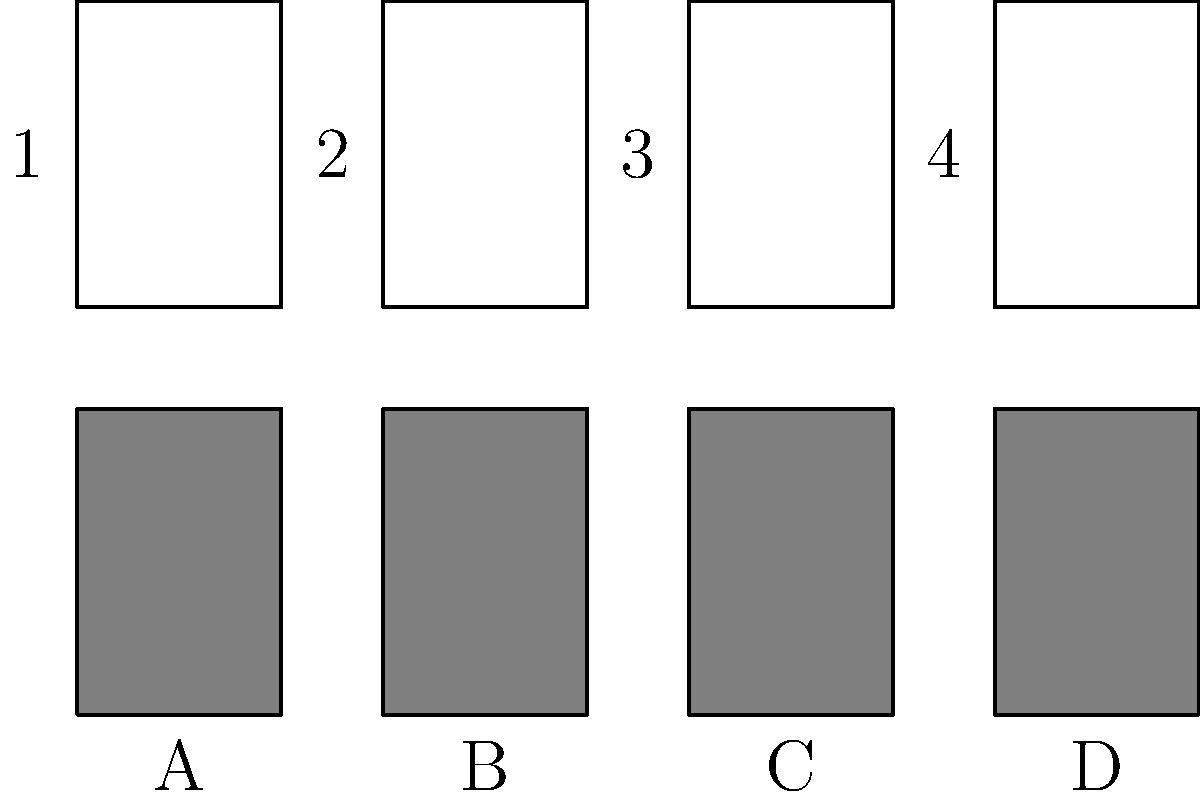As a talent show judge who knows the importance of a celebrity's image, match the celebrity faces (1-4) with their corresponding silhouettes (A-D). Which combination would create the most buzz-worthy reveal on our next episode? To match the celebrity faces with their silhouettes, we need to analyze the shapes and distinctive features of both the faces and silhouettes. Let's break it down step-by-step:

1. Face 1 has a round shape with what appears to be voluminous hair. This matches best with Silhouette C, which shows a fuller head shape.

2. Face 2 has a more angular jawline and what seems to be shorter hair. This corresponds well with Silhouette A, which has a sharper outline.

3. Face 3 shows a face with distinctive features, possibly larger ears or a unique hairstyle. This matches Silhouette D, which has a more complex outline.

4. Face 4 has a smoother, oval shape, which fits best with Silhouette B's softer contours.

5. For the most buzz-worthy reveal, we should consider which celebrity might create the most surprise or excitement when paired with their silhouette. Given the distinctive features of Face 3 and Silhouette D, this pairing would likely create the most dramatic reveal.

Therefore, the most buzz-worthy combination would be:
1-C, 2-A, 3-D, 4-B, with special emphasis on the 3-D pairing for maximum audience impact.
Answer: 1-C, 2-A, 3-D, 4-B (emphasize 3-D) 